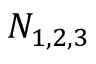<formula> <loc_0><loc_0><loc_500><loc_500>N _ { 1 , 2 , 3 }</formula> 